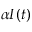<formula> <loc_0><loc_0><loc_500><loc_500>\alpha I ( t )</formula> 